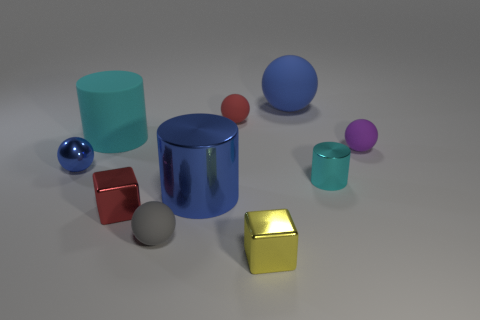The object that is in front of the tiny metallic sphere and to the right of the blue matte thing is what color?
Make the answer very short. Cyan. Are there any other things that have the same material as the tiny red ball?
Ensure brevity in your answer.  Yes. Is the number of gray rubber things in front of the large shiny cylinder less than the number of red cubes that are behind the small red sphere?
Offer a very short reply. No. What shape is the small blue metal thing?
Your answer should be compact. Sphere. What color is the big cylinder that is the same material as the gray ball?
Keep it short and to the point. Cyan. Is the number of cyan shiny cylinders greater than the number of big brown matte objects?
Your response must be concise. Yes. Are there any small matte balls?
Ensure brevity in your answer.  Yes. There is a small metal thing to the right of the blue ball on the right side of the small yellow shiny cube; what shape is it?
Offer a very short reply. Cylinder. What number of objects are either large blue shiny things or blocks that are in front of the tiny blue metal object?
Make the answer very short. 3. There is a big matte thing to the right of the small red object that is on the right side of the small rubber object that is to the left of the large blue shiny cylinder; what color is it?
Your answer should be very brief. Blue. 